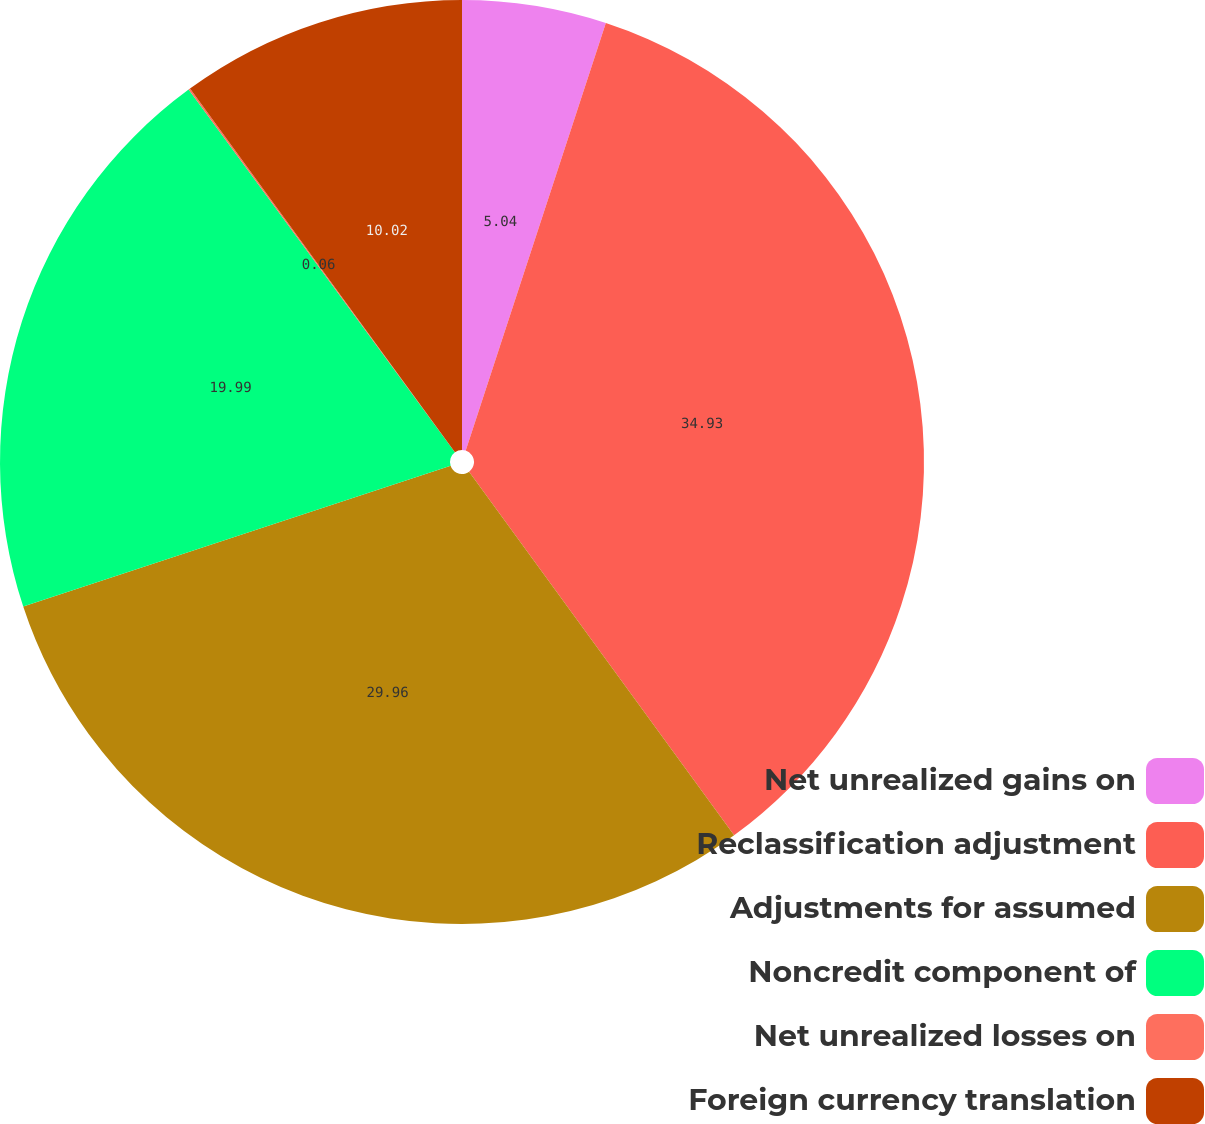Convert chart. <chart><loc_0><loc_0><loc_500><loc_500><pie_chart><fcel>Net unrealized gains on<fcel>Reclassification adjustment<fcel>Adjustments for assumed<fcel>Noncredit component of<fcel>Net unrealized losses on<fcel>Foreign currency translation<nl><fcel>5.04%<fcel>34.94%<fcel>29.96%<fcel>19.99%<fcel>0.06%<fcel>10.02%<nl></chart> 